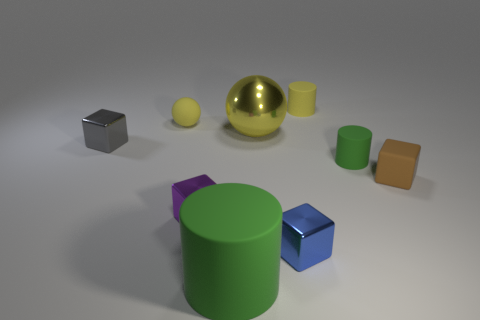Can you describe the objects on the left side of the image? On the left side of the image, there is a collection of geometric shapes. Closest to the edge lies a small metallic cube, reflecting a dim light. Slightly to the right, there is a matte yellow sphere and a reflective golden sphere that catches the eye with its sheen. 